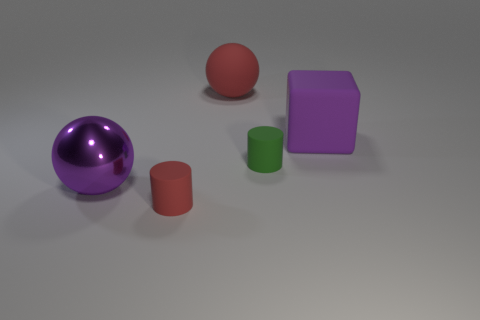Can you speculate on the purpose of this arrangement? The arrangement of objects in the image seems to be a deliberate setup, possibly for a study of geometry, colors, and materials in visual arts or photography. It could be an educational tool to show the contrast between different shapes, such as cylinders, a sphere, a hemisphere, and a cube-like block, and to discuss the principles of light, reflection, and shadow on different surfaces. What might you infer about the light source in the scene? The soft shadows cast by the objects and the subtle highlights on the metallic surfaces suggest the presence of a diffuse and possibly singular light source. It resembles studio lighting, where a softer light is used to gently illuminate the scene without creating harsh shadows, enabling clear observation of the object features. 